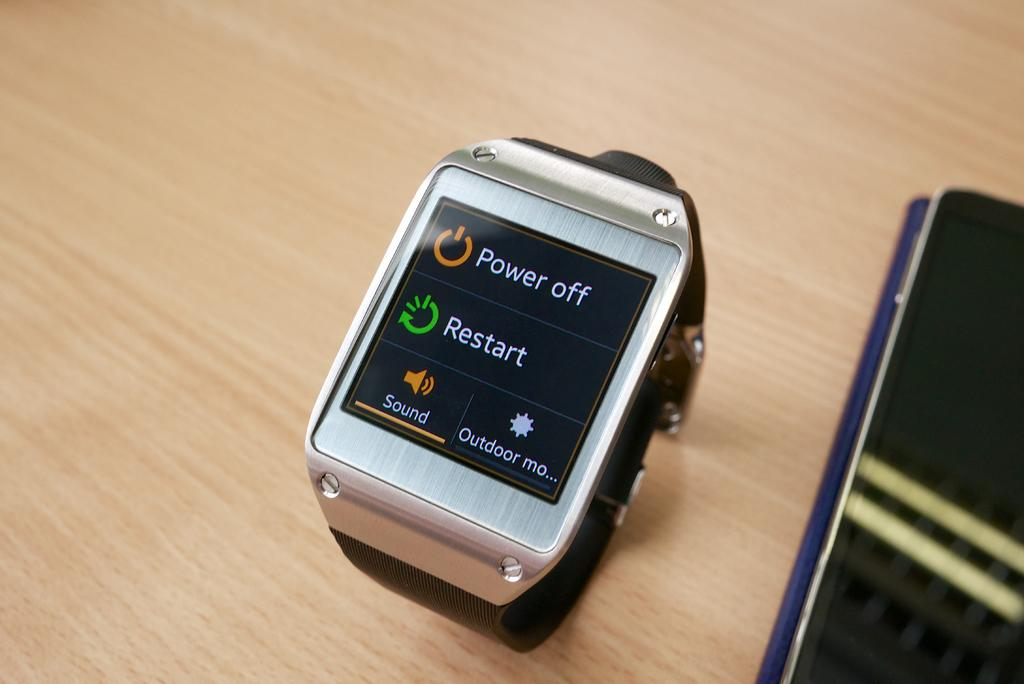<image>
Describe the image concisely. A smart watch says power off and restart on the screen. 